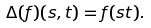<formula> <loc_0><loc_0><loc_500><loc_500>\Delta ( f ) ( s , t ) = f ( s t ) .</formula> 